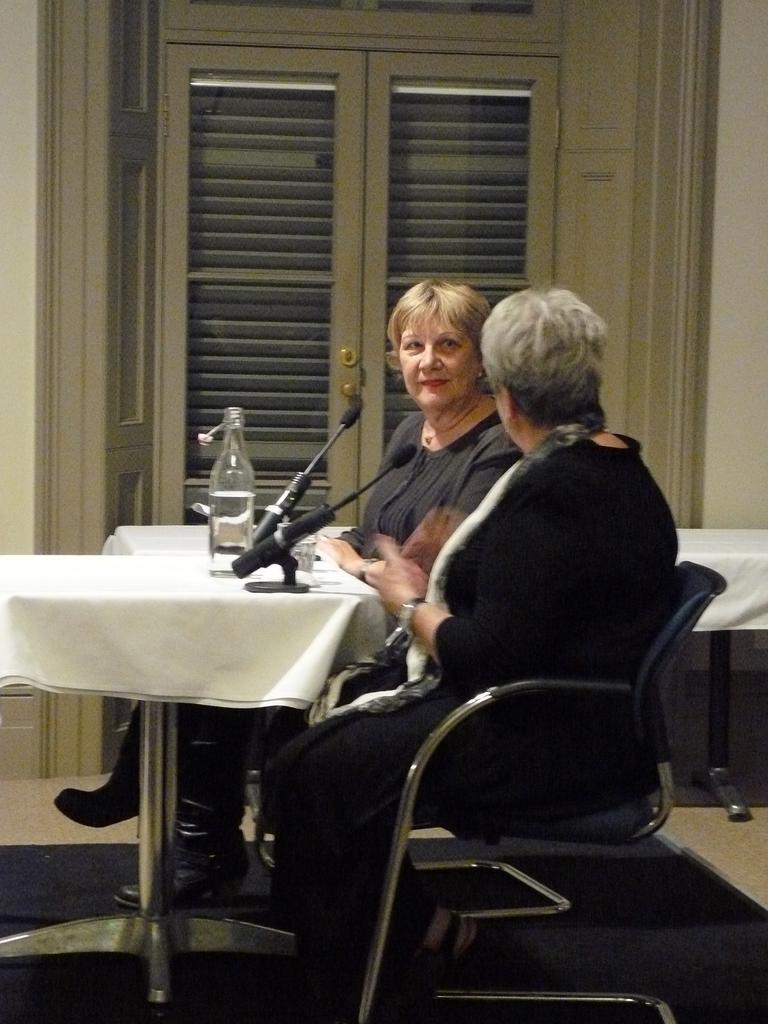Describe this image in one or two sentences. In this image i can see two persons sitting on a chair,there is a micro phone,a bottle on a table. At the background there is a door. 